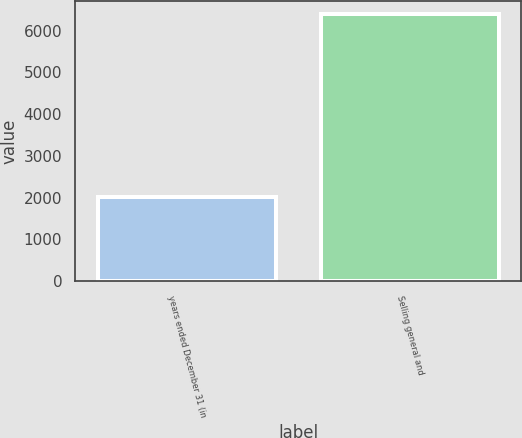Convert chart. <chart><loc_0><loc_0><loc_500><loc_500><bar_chart><fcel>years ended December 31 (in<fcel>Selling general and<nl><fcel>2015<fcel>6387<nl></chart> 